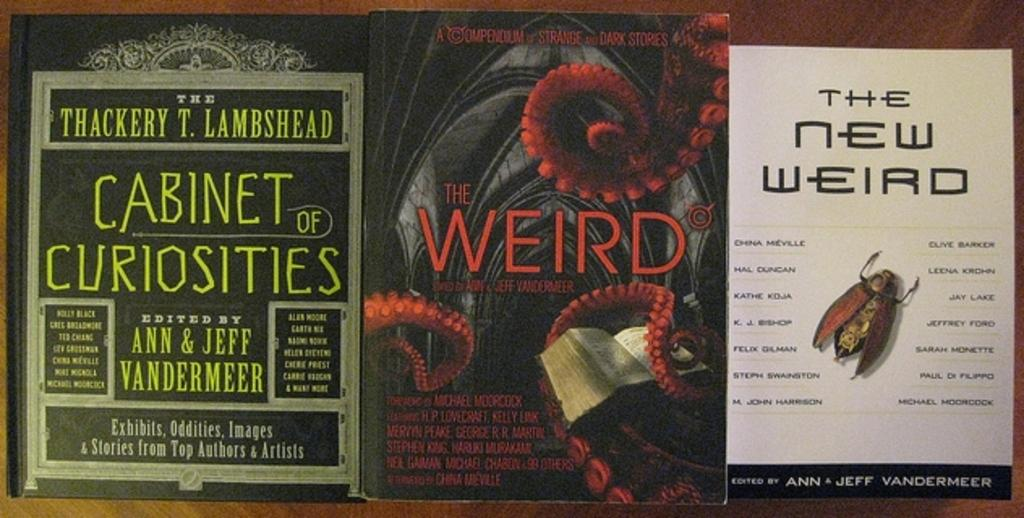<image>
Create a compact narrative representing the image presented. Three books including Cabinet of Curiosities and Weird. 